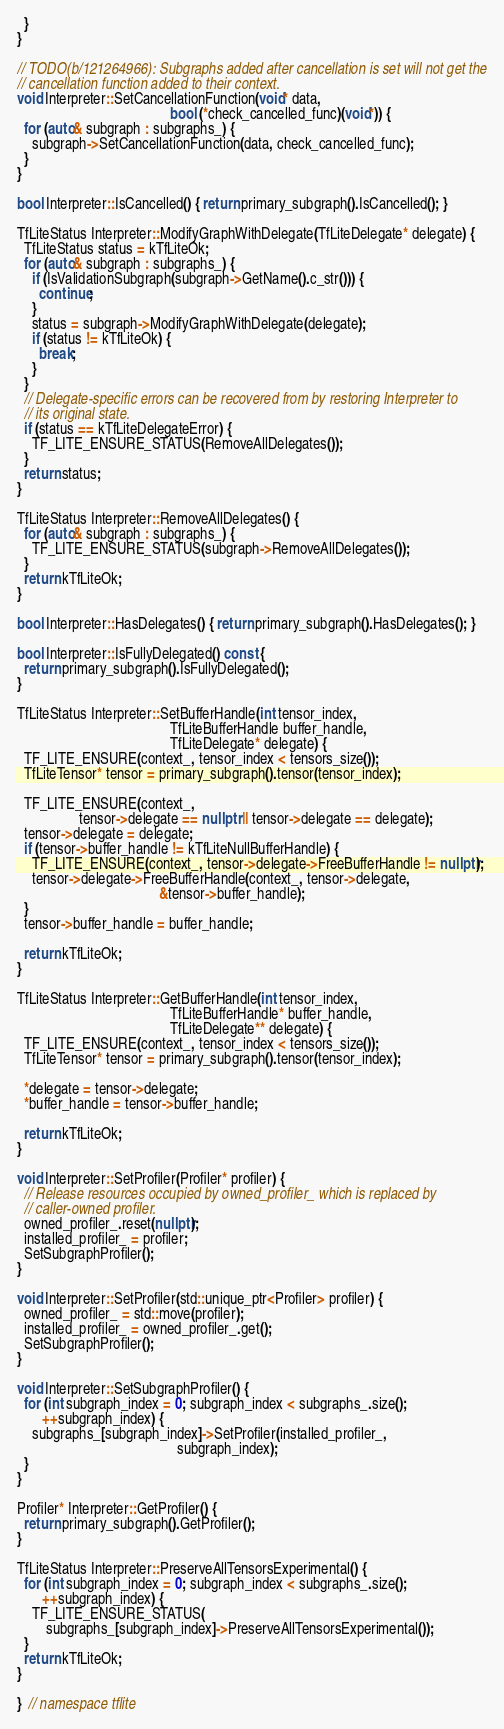Convert code to text. <code><loc_0><loc_0><loc_500><loc_500><_C++_>  }
}

// TODO(b/121264966): Subgraphs added after cancellation is set will not get the
// cancellation function added to their context.
void Interpreter::SetCancellationFunction(void* data,
                                          bool (*check_cancelled_func)(void*)) {
  for (auto& subgraph : subgraphs_) {
    subgraph->SetCancellationFunction(data, check_cancelled_func);
  }
}

bool Interpreter::IsCancelled() { return primary_subgraph().IsCancelled(); }

TfLiteStatus Interpreter::ModifyGraphWithDelegate(TfLiteDelegate* delegate) {
  TfLiteStatus status = kTfLiteOk;
  for (auto& subgraph : subgraphs_) {
    if (IsValidationSubgraph(subgraph->GetName().c_str())) {
      continue;
    }
    status = subgraph->ModifyGraphWithDelegate(delegate);
    if (status != kTfLiteOk) {
      break;
    }
  }
  // Delegate-specific errors can be recovered from by restoring Interpreter to
  // its original state.
  if (status == kTfLiteDelegateError) {
    TF_LITE_ENSURE_STATUS(RemoveAllDelegates());
  }
  return status;
}

TfLiteStatus Interpreter::RemoveAllDelegates() {
  for (auto& subgraph : subgraphs_) {
    TF_LITE_ENSURE_STATUS(subgraph->RemoveAllDelegates());
  }
  return kTfLiteOk;
}

bool Interpreter::HasDelegates() { return primary_subgraph().HasDelegates(); }

bool Interpreter::IsFullyDelegated() const {
  return primary_subgraph().IsFullyDelegated();
}

TfLiteStatus Interpreter::SetBufferHandle(int tensor_index,
                                          TfLiteBufferHandle buffer_handle,
                                          TfLiteDelegate* delegate) {
  TF_LITE_ENSURE(context_, tensor_index < tensors_size());
  TfLiteTensor* tensor = primary_subgraph().tensor(tensor_index);

  TF_LITE_ENSURE(context_,
                 tensor->delegate == nullptr || tensor->delegate == delegate);
  tensor->delegate = delegate;
  if (tensor->buffer_handle != kTfLiteNullBufferHandle) {
    TF_LITE_ENSURE(context_, tensor->delegate->FreeBufferHandle != nullptr);
    tensor->delegate->FreeBufferHandle(context_, tensor->delegate,
                                       &tensor->buffer_handle);
  }
  tensor->buffer_handle = buffer_handle;

  return kTfLiteOk;
}

TfLiteStatus Interpreter::GetBufferHandle(int tensor_index,
                                          TfLiteBufferHandle* buffer_handle,
                                          TfLiteDelegate** delegate) {
  TF_LITE_ENSURE(context_, tensor_index < tensors_size());
  TfLiteTensor* tensor = primary_subgraph().tensor(tensor_index);

  *delegate = tensor->delegate;
  *buffer_handle = tensor->buffer_handle;

  return kTfLiteOk;
}

void Interpreter::SetProfiler(Profiler* profiler) {
  // Release resources occupied by owned_profiler_ which is replaced by
  // caller-owned profiler.
  owned_profiler_.reset(nullptr);
  installed_profiler_ = profiler;
  SetSubgraphProfiler();
}

void Interpreter::SetProfiler(std::unique_ptr<Profiler> profiler) {
  owned_profiler_ = std::move(profiler);
  installed_profiler_ = owned_profiler_.get();
  SetSubgraphProfiler();
}

void Interpreter::SetSubgraphProfiler() {
  for (int subgraph_index = 0; subgraph_index < subgraphs_.size();
       ++subgraph_index) {
    subgraphs_[subgraph_index]->SetProfiler(installed_profiler_,
                                            subgraph_index);
  }
}

Profiler* Interpreter::GetProfiler() {
  return primary_subgraph().GetProfiler();
}

TfLiteStatus Interpreter::PreserveAllTensorsExperimental() {
  for (int subgraph_index = 0; subgraph_index < subgraphs_.size();
       ++subgraph_index) {
    TF_LITE_ENSURE_STATUS(
        subgraphs_[subgraph_index]->PreserveAllTensorsExperimental());
  }
  return kTfLiteOk;
}

}  // namespace tflite
</code> 